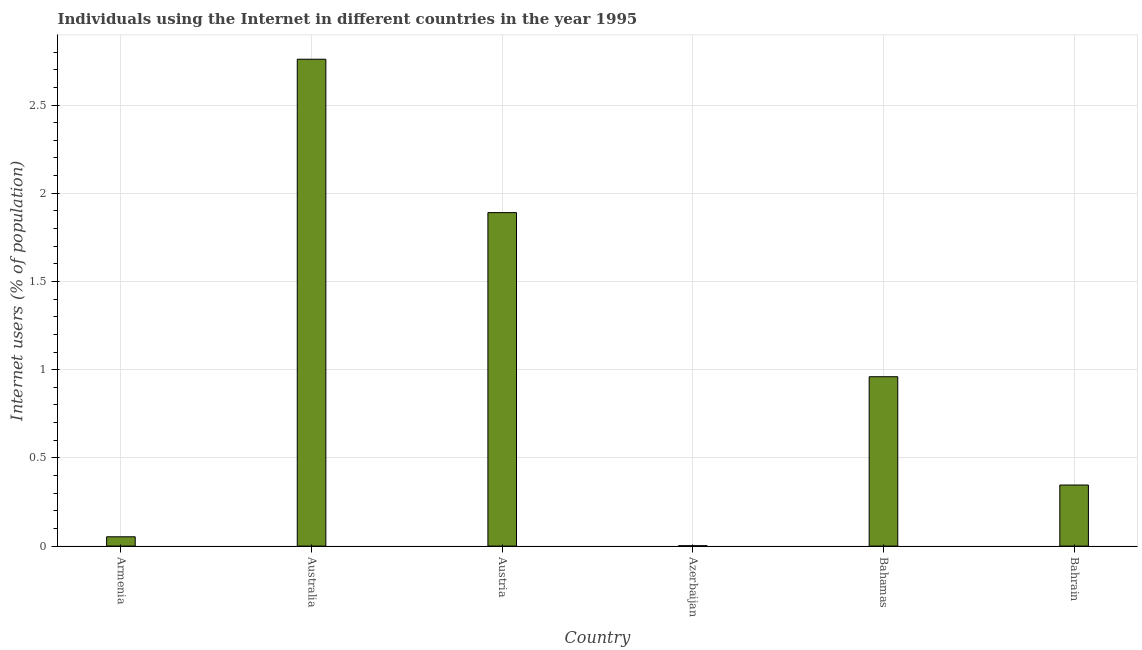Does the graph contain grids?
Provide a short and direct response. Yes. What is the title of the graph?
Your response must be concise. Individuals using the Internet in different countries in the year 1995. What is the label or title of the Y-axis?
Provide a succinct answer. Internet users (% of population). What is the number of internet users in Australia?
Offer a very short reply. 2.76. Across all countries, what is the maximum number of internet users?
Give a very brief answer. 2.76. Across all countries, what is the minimum number of internet users?
Provide a succinct answer. 0. In which country was the number of internet users maximum?
Make the answer very short. Australia. In which country was the number of internet users minimum?
Give a very brief answer. Azerbaijan. What is the sum of the number of internet users?
Keep it short and to the point. 6.01. What is the difference between the number of internet users in Armenia and Azerbaijan?
Your answer should be compact. 0.05. What is the average number of internet users per country?
Provide a short and direct response. 1. What is the median number of internet users?
Offer a terse response. 0.65. What is the ratio of the number of internet users in Austria to that in Azerbaijan?
Offer a very short reply. 919.56. Is the number of internet users in Azerbaijan less than that in Bahrain?
Give a very brief answer. Yes. Is the difference between the number of internet users in Armenia and Bahrain greater than the difference between any two countries?
Provide a succinct answer. No. What is the difference between the highest and the second highest number of internet users?
Make the answer very short. 0.87. Is the sum of the number of internet users in Armenia and Azerbaijan greater than the maximum number of internet users across all countries?
Provide a short and direct response. No. What is the difference between the highest and the lowest number of internet users?
Offer a very short reply. 2.76. Are all the bars in the graph horizontal?
Offer a very short reply. No. What is the Internet users (% of population) of Armenia?
Give a very brief answer. 0.05. What is the Internet users (% of population) in Australia?
Ensure brevity in your answer.  2.76. What is the Internet users (% of population) in Austria?
Your answer should be compact. 1.89. What is the Internet users (% of population) of Azerbaijan?
Keep it short and to the point. 0. What is the Internet users (% of population) in Bahamas?
Provide a succinct answer. 0.96. What is the Internet users (% of population) of Bahrain?
Your answer should be very brief. 0.35. What is the difference between the Internet users (% of population) in Armenia and Australia?
Give a very brief answer. -2.71. What is the difference between the Internet users (% of population) in Armenia and Austria?
Offer a terse response. -1.84. What is the difference between the Internet users (% of population) in Armenia and Azerbaijan?
Make the answer very short. 0.05. What is the difference between the Internet users (% of population) in Armenia and Bahamas?
Keep it short and to the point. -0.91. What is the difference between the Internet users (% of population) in Armenia and Bahrain?
Make the answer very short. -0.29. What is the difference between the Internet users (% of population) in Australia and Austria?
Make the answer very short. 0.87. What is the difference between the Internet users (% of population) in Australia and Azerbaijan?
Offer a very short reply. 2.76. What is the difference between the Internet users (% of population) in Australia and Bahamas?
Your response must be concise. 1.8. What is the difference between the Internet users (% of population) in Australia and Bahrain?
Provide a succinct answer. 2.41. What is the difference between the Internet users (% of population) in Austria and Azerbaijan?
Give a very brief answer. 1.89. What is the difference between the Internet users (% of population) in Austria and Bahamas?
Your response must be concise. 0.93. What is the difference between the Internet users (% of population) in Austria and Bahrain?
Offer a very short reply. 1.54. What is the difference between the Internet users (% of population) in Azerbaijan and Bahamas?
Ensure brevity in your answer.  -0.96. What is the difference between the Internet users (% of population) in Azerbaijan and Bahrain?
Keep it short and to the point. -0.34. What is the difference between the Internet users (% of population) in Bahamas and Bahrain?
Your answer should be compact. 0.61. What is the ratio of the Internet users (% of population) in Armenia to that in Australia?
Offer a terse response. 0.02. What is the ratio of the Internet users (% of population) in Armenia to that in Austria?
Give a very brief answer. 0.03. What is the ratio of the Internet users (% of population) in Armenia to that in Azerbaijan?
Your answer should be compact. 25.66. What is the ratio of the Internet users (% of population) in Armenia to that in Bahamas?
Give a very brief answer. 0.06. What is the ratio of the Internet users (% of population) in Armenia to that in Bahrain?
Your response must be concise. 0.15. What is the ratio of the Internet users (% of population) in Australia to that in Austria?
Provide a short and direct response. 1.46. What is the ratio of the Internet users (% of population) in Australia to that in Azerbaijan?
Your answer should be compact. 1342.53. What is the ratio of the Internet users (% of population) in Australia to that in Bahamas?
Keep it short and to the point. 2.88. What is the ratio of the Internet users (% of population) in Australia to that in Bahrain?
Give a very brief answer. 7.97. What is the ratio of the Internet users (% of population) in Austria to that in Azerbaijan?
Make the answer very short. 919.56. What is the ratio of the Internet users (% of population) in Austria to that in Bahamas?
Ensure brevity in your answer.  1.97. What is the ratio of the Internet users (% of population) in Austria to that in Bahrain?
Ensure brevity in your answer.  5.46. What is the ratio of the Internet users (% of population) in Azerbaijan to that in Bahamas?
Your answer should be very brief. 0. What is the ratio of the Internet users (% of population) in Azerbaijan to that in Bahrain?
Your answer should be compact. 0.01. What is the ratio of the Internet users (% of population) in Bahamas to that in Bahrain?
Offer a very short reply. 2.77. 